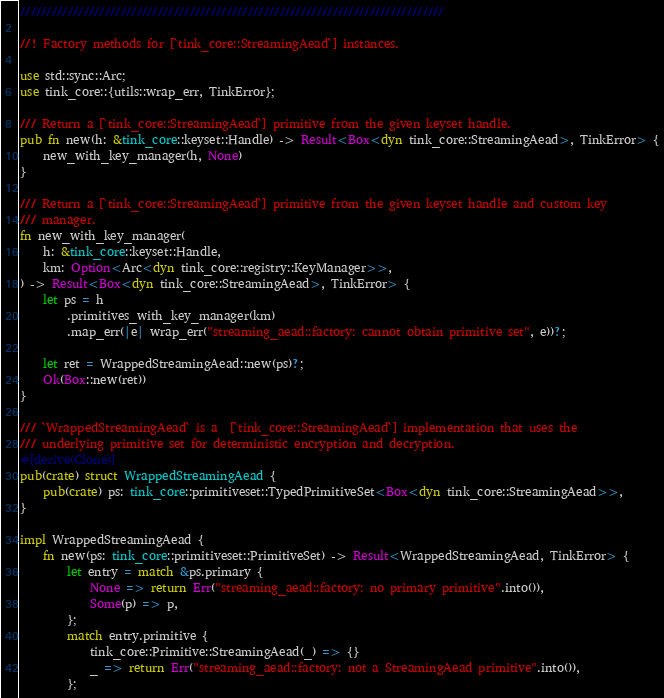<code> <loc_0><loc_0><loc_500><loc_500><_Rust_>////////////////////////////////////////////////////////////////////////////////

//! Factory methods for [`tink_core::StreamingAead`] instances.

use std::sync::Arc;
use tink_core::{utils::wrap_err, TinkError};

/// Return a [`tink_core::StreamingAead`] primitive from the given keyset handle.
pub fn new(h: &tink_core::keyset::Handle) -> Result<Box<dyn tink_core::StreamingAead>, TinkError> {
    new_with_key_manager(h, None)
}

/// Return a [`tink_core::StreamingAead`] primitive from the given keyset handle and custom key
/// manager.
fn new_with_key_manager(
    h: &tink_core::keyset::Handle,
    km: Option<Arc<dyn tink_core::registry::KeyManager>>,
) -> Result<Box<dyn tink_core::StreamingAead>, TinkError> {
    let ps = h
        .primitives_with_key_manager(km)
        .map_err(|e| wrap_err("streaming_aead::factory: cannot obtain primitive set", e))?;

    let ret = WrappedStreamingAead::new(ps)?;
    Ok(Box::new(ret))
}

/// `WrappedStreamingAead` is a  [`tink_core::StreamingAead`] implementation that uses the
/// underlying primitive set for deterministic encryption and decryption.
#[derive(Clone)]
pub(crate) struct WrappedStreamingAead {
    pub(crate) ps: tink_core::primitiveset::TypedPrimitiveSet<Box<dyn tink_core::StreamingAead>>,
}

impl WrappedStreamingAead {
    fn new(ps: tink_core::primitiveset::PrimitiveSet) -> Result<WrappedStreamingAead, TinkError> {
        let entry = match &ps.primary {
            None => return Err("streaming_aead::factory: no primary primitive".into()),
            Some(p) => p,
        };
        match entry.primitive {
            tink_core::Primitive::StreamingAead(_) => {}
            _ => return Err("streaming_aead::factory: not a StreamingAead primitive".into()),
        };</code> 